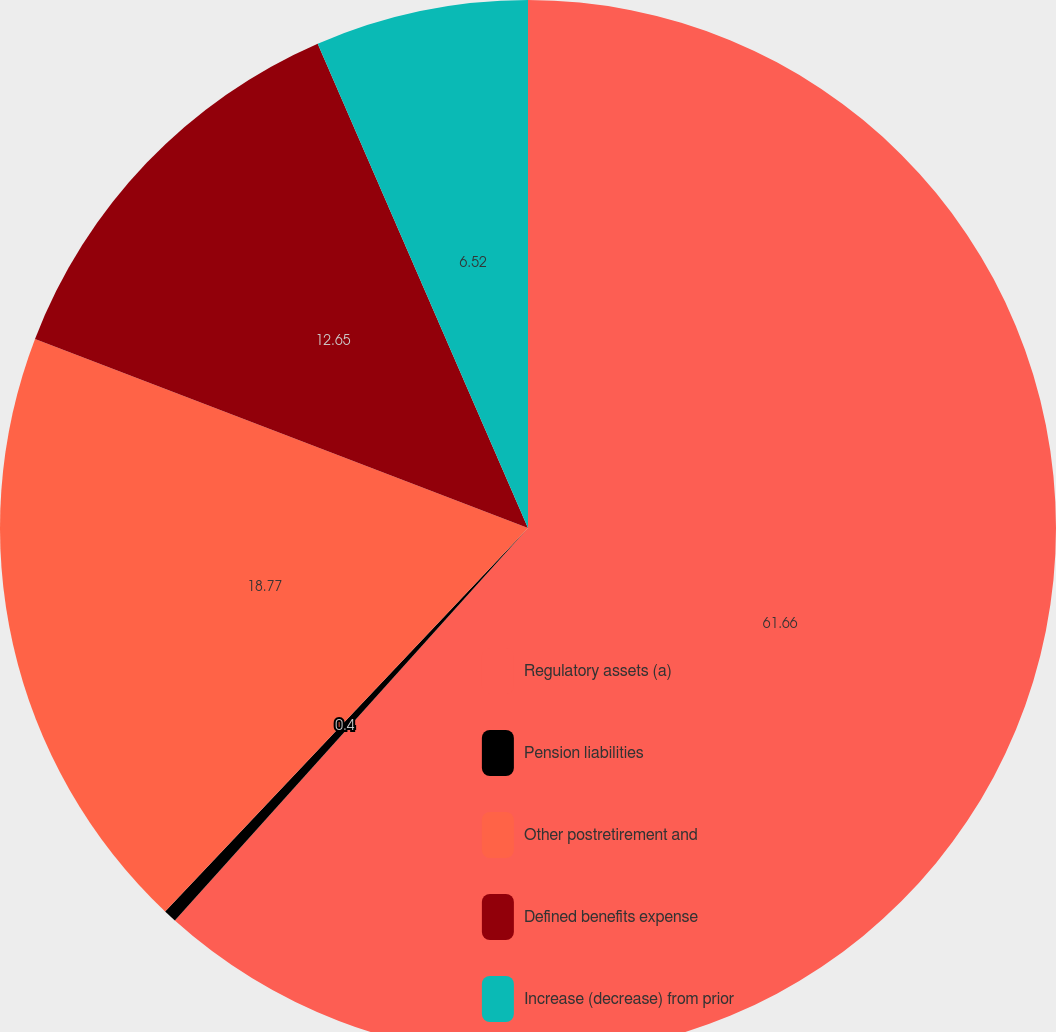Convert chart. <chart><loc_0><loc_0><loc_500><loc_500><pie_chart><fcel>Regulatory assets (a)<fcel>Pension liabilities<fcel>Other postretirement and<fcel>Defined benefits expense<fcel>Increase (decrease) from prior<nl><fcel>61.66%<fcel>0.4%<fcel>18.77%<fcel>12.65%<fcel>6.52%<nl></chart> 